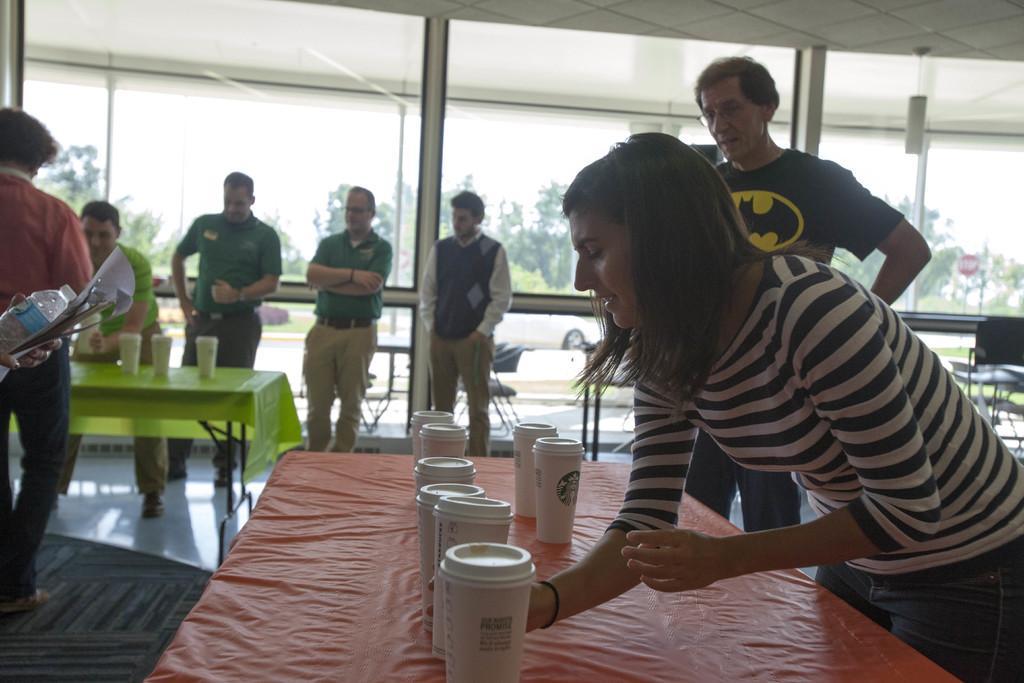In one or two sentences, can you explain what this image depicts? in this image there is a room in this room there are many tables and chairs and all people they are standing on floor and the back ground is sunny. 